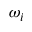<formula> <loc_0><loc_0><loc_500><loc_500>\omega _ { i }</formula> 